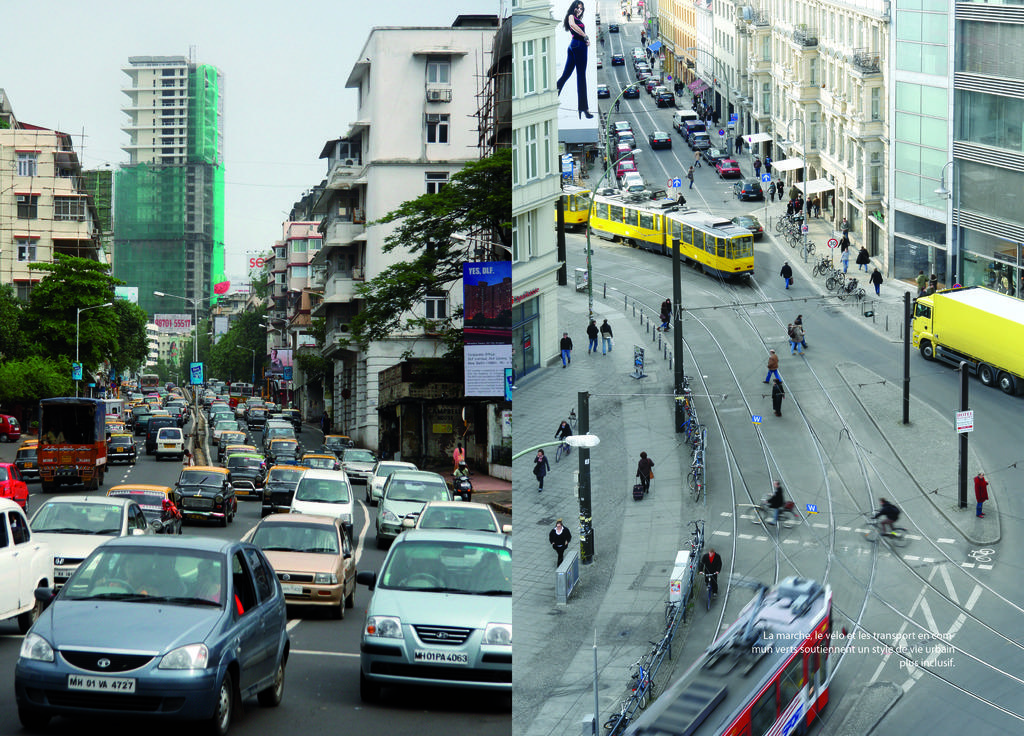What type of artwork is the image? The image is a collage. What can be seen on the roads in the image? There are vehicles on roads in the image. Who or what is present in the image? There are people in the image. What structures are visible in the image? There are buildings in the image. What type of vegetation is present in the image? There are trees in the image. What other objects can be seen in the image? There are poles and banners in the image. What is visible in the background of the image? The sky is visible in the background of the image. How does the writer interact with the vehicles in the image? There is no writer present in the image. The image is a collage featuring various elements, but no writer interacting with the vehicles. 